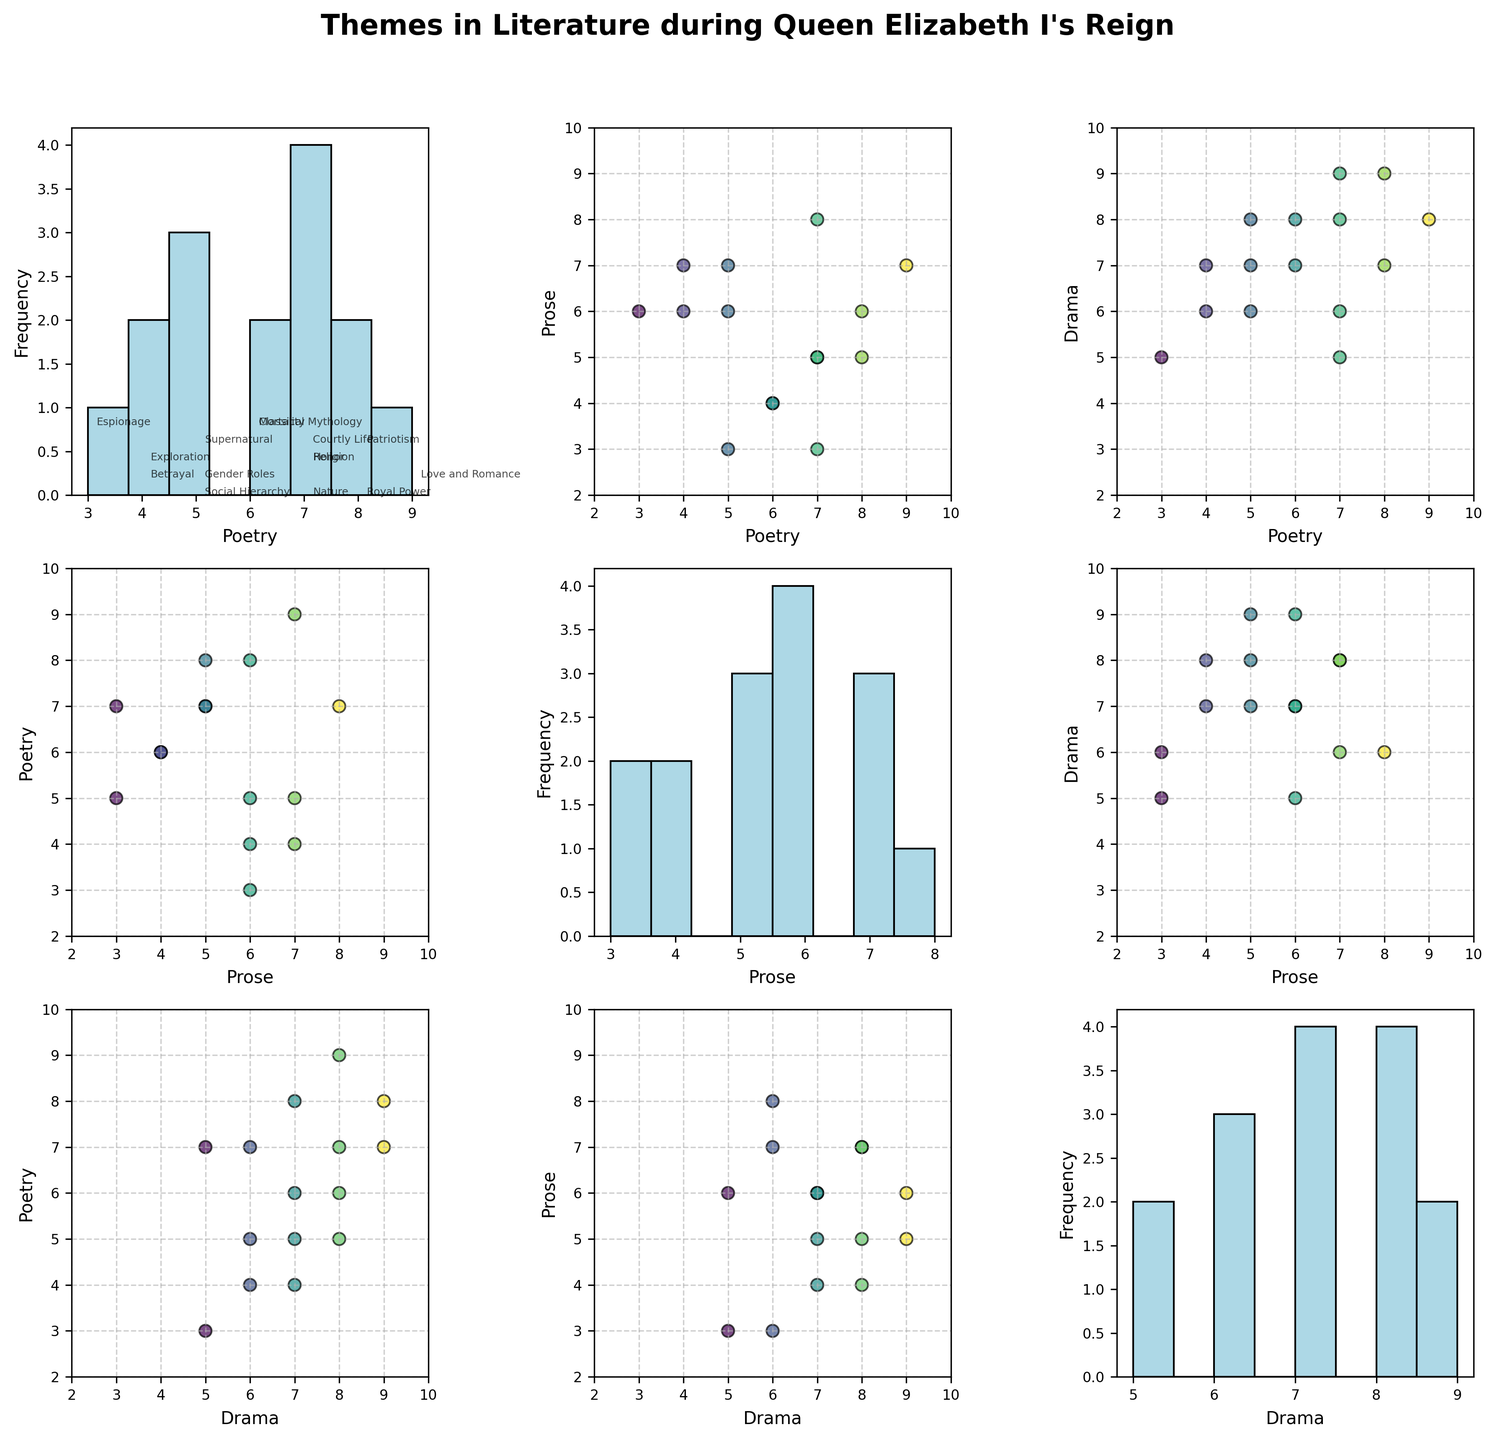What is the title of the scatterplot matrix? The title can be found at the top of the figure. It serves as a summary of what the scatterplot matrix represents.
Answer: Themes in Literature during Queen Elizabeth I's Reign How many distinct genres are compared in this scatterplot matrix? Look at the axis labels as each genre will be labeled on both the x and y axes. This will indicate the number of genres being compared.
Answer: Three (Poetry, Prose, Drama) Which theme has the highest frequency in Poetry based on the histogram? Identify the histogram on the diagonal corresponding to the Poetry column. Observe which bin has the highest bar. The theme with the highest bar will correspond to the highest frequency.
Answer: Love and Romance Is the theme of Royal Power more prevalent in Drama or Prose? Examine the scatter plot where Drama is on one axis and Prose is on the other. Locate the data points for Royal Power and compare their values to see which one is higher.
Answer: Drama What are the x and y axes of the scatter plot that compares Poetry and Drama? Locate the scatter plot with Poetry on one axis and Drama on the other. The axes will be labeled with the genres they are comparing.
Answer: Poetry (x-axis) and Drama (y-axis) Which genre has the least variety of themes based on the range of values in the scatterplots? Assess the range of values in the scatter plots on the diagonal, specifically looking at the histograms for each genre. The genre with the smallest range has the least variety.
Answer: Nature (Histogram shows fewer distinct values) Which themes are located in the scatter plot comparing Poetry and Prose with the highest Poetry values? Locate the scatter plot with Poetry on one axis and Prose on the other. Identify data points with the highest Poetry values, and look at their corresponding themes.
Answer: Love and Romance, Royal Power, Patriotism What is the average value of the theme 'Patriotism' across Poetry, Prose, and Drama? Sum the values of the theme 'Patriotism' in Poetry, Prose, and Drama, then divide by the number of genres (which is 3). Calculate: (8+5+7)/3 = 6.67
Answer: 6.67 Is there a theme that appears equally across all three genres (Poetry, Prose, and Drama)? Compare the values of all themes across all three genres. Find if there is a theme where the values in Poetry, Prose, and Drama are identical.
Answer: No, there is no theme with equal values across Poetry, Prose, and Drama Which genre tends to have the lowest scores on themes related to Nature? Compare the data points for Nature across the three genres (Poetry, Prose, Drama). Determine which genre has the lowest value for Nature.
Answer: Prose 